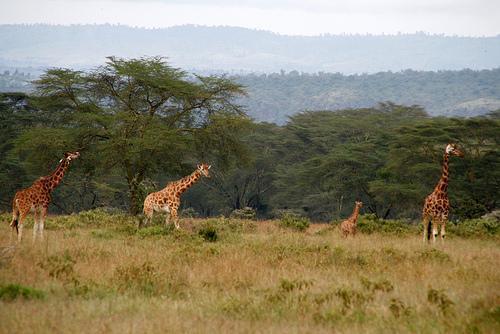How many giraffes are there?
Give a very brief answer. 4. 